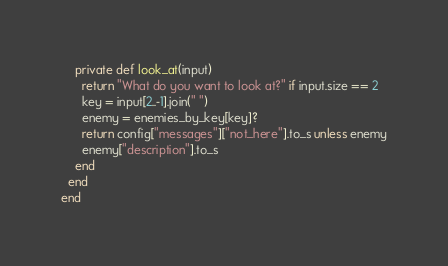<code> <loc_0><loc_0><loc_500><loc_500><_Crystal_>    private def look_at(input)
      return "What do you want to look at?" if input.size == 2
      key = input[2..-1].join(" ")
      enemy = enemies_by_key[key]?
      return config["messages"]["not_here"].to_s unless enemy
      enemy["description"].to_s
    end
  end
end
</code> 